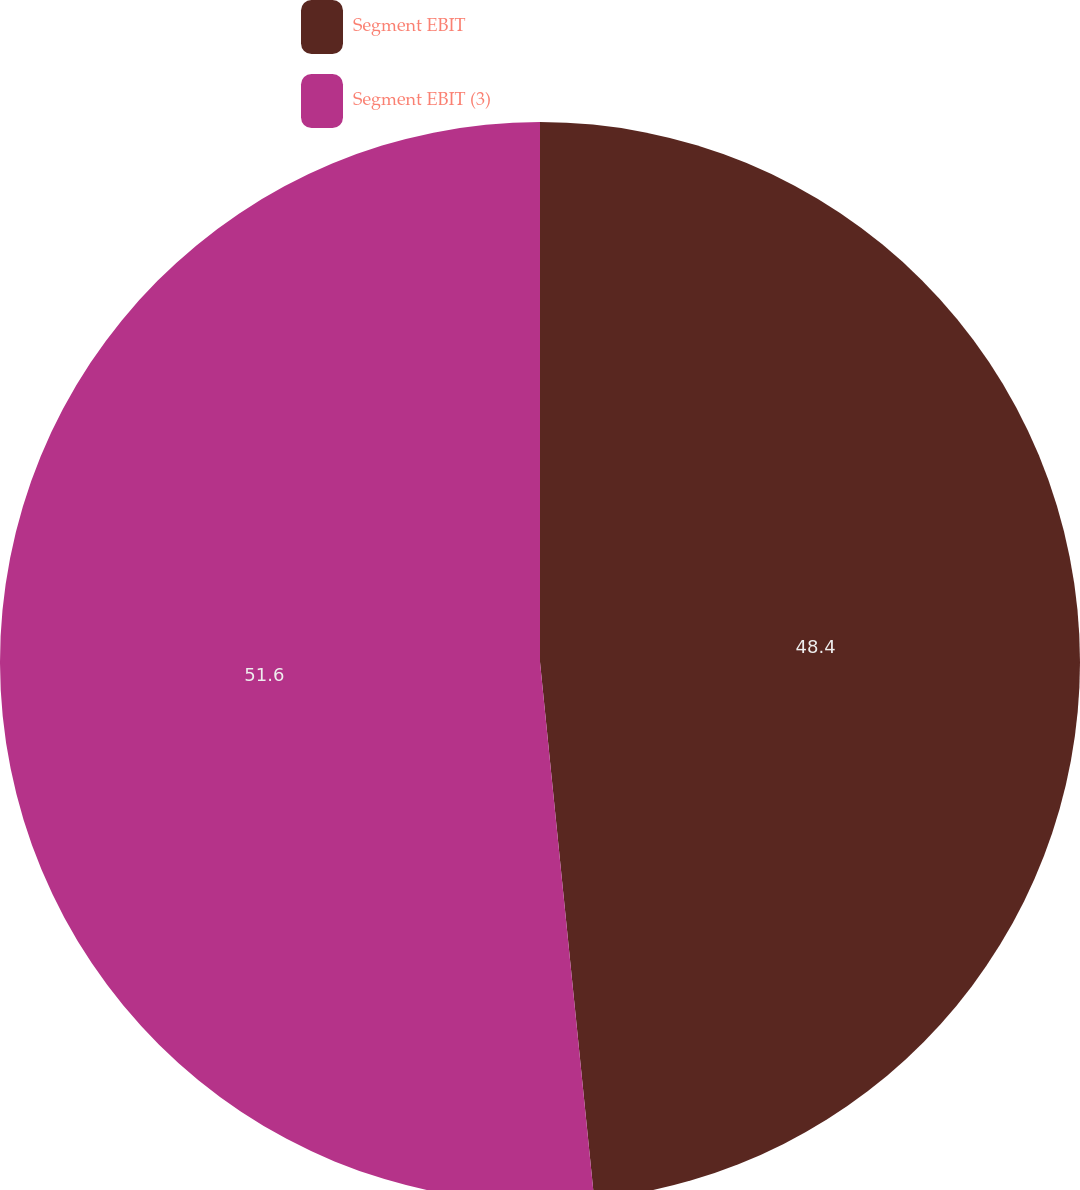Convert chart to OTSL. <chart><loc_0><loc_0><loc_500><loc_500><pie_chart><fcel>Segment EBIT<fcel>Segment EBIT (3)<nl><fcel>48.4%<fcel>51.6%<nl></chart> 